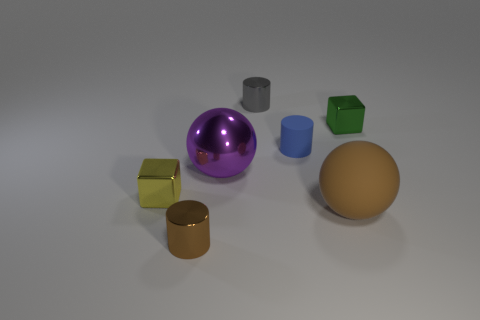Add 2 brown things. How many objects exist? 9 Subtract all spheres. How many objects are left? 5 Add 2 large purple rubber cylinders. How many large purple rubber cylinders exist? 2 Subtract 0 yellow balls. How many objects are left? 7 Subtract all large green metallic balls. Subtract all cubes. How many objects are left? 5 Add 4 tiny blue rubber cylinders. How many tiny blue rubber cylinders are left? 5 